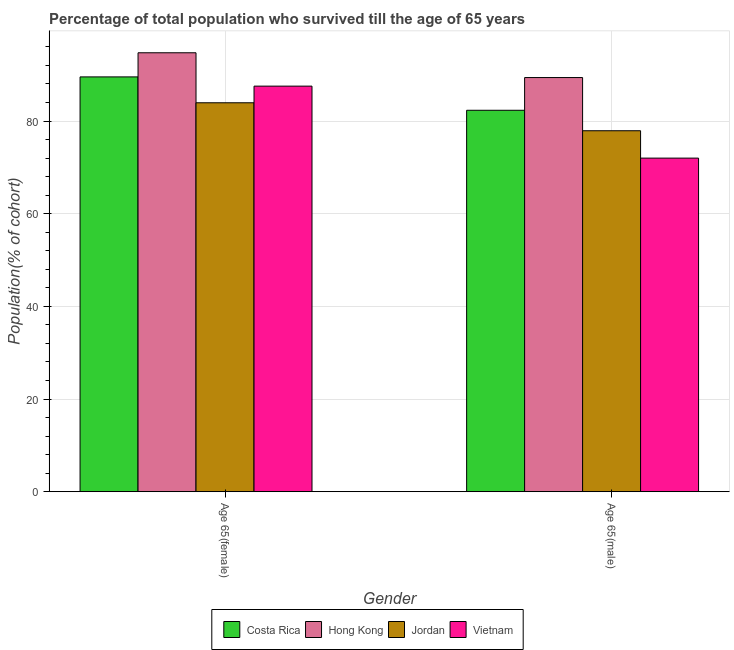How many groups of bars are there?
Give a very brief answer. 2. Are the number of bars per tick equal to the number of legend labels?
Give a very brief answer. Yes. Are the number of bars on each tick of the X-axis equal?
Provide a succinct answer. Yes. How many bars are there on the 2nd tick from the right?
Provide a short and direct response. 4. What is the label of the 2nd group of bars from the left?
Provide a succinct answer. Age 65(male). What is the percentage of male population who survived till age of 65 in Jordan?
Your answer should be compact. 77.9. Across all countries, what is the maximum percentage of male population who survived till age of 65?
Offer a very short reply. 89.37. Across all countries, what is the minimum percentage of female population who survived till age of 65?
Ensure brevity in your answer.  83.93. In which country was the percentage of male population who survived till age of 65 maximum?
Offer a very short reply. Hong Kong. In which country was the percentage of male population who survived till age of 65 minimum?
Ensure brevity in your answer.  Vietnam. What is the total percentage of male population who survived till age of 65 in the graph?
Provide a short and direct response. 321.58. What is the difference between the percentage of male population who survived till age of 65 in Hong Kong and that in Costa Rica?
Offer a very short reply. 7.06. What is the difference between the percentage of female population who survived till age of 65 in Vietnam and the percentage of male population who survived till age of 65 in Jordan?
Offer a very short reply. 9.63. What is the average percentage of male population who survived till age of 65 per country?
Offer a terse response. 80.39. What is the difference between the percentage of female population who survived till age of 65 and percentage of male population who survived till age of 65 in Vietnam?
Offer a very short reply. 15.53. In how many countries, is the percentage of male population who survived till age of 65 greater than 48 %?
Your response must be concise. 4. What is the ratio of the percentage of male population who survived till age of 65 in Hong Kong to that in Vietnam?
Provide a succinct answer. 1.24. In how many countries, is the percentage of female population who survived till age of 65 greater than the average percentage of female population who survived till age of 65 taken over all countries?
Offer a very short reply. 2. What does the 2nd bar from the left in Age 65(female) represents?
Provide a short and direct response. Hong Kong. What does the 1st bar from the right in Age 65(male) represents?
Offer a terse response. Vietnam. Are all the bars in the graph horizontal?
Your answer should be very brief. No. How many countries are there in the graph?
Keep it short and to the point. 4. Are the values on the major ticks of Y-axis written in scientific E-notation?
Provide a succinct answer. No. Does the graph contain any zero values?
Keep it short and to the point. No. Does the graph contain grids?
Offer a terse response. Yes. How many legend labels are there?
Your response must be concise. 4. How are the legend labels stacked?
Offer a terse response. Horizontal. What is the title of the graph?
Give a very brief answer. Percentage of total population who survived till the age of 65 years. Does "North America" appear as one of the legend labels in the graph?
Keep it short and to the point. No. What is the label or title of the Y-axis?
Offer a very short reply. Population(% of cohort). What is the Population(% of cohort) of Costa Rica in Age 65(female)?
Your response must be concise. 89.52. What is the Population(% of cohort) of Hong Kong in Age 65(female)?
Your response must be concise. 94.72. What is the Population(% of cohort) of Jordan in Age 65(female)?
Provide a short and direct response. 83.93. What is the Population(% of cohort) of Vietnam in Age 65(female)?
Give a very brief answer. 87.52. What is the Population(% of cohort) in Costa Rica in Age 65(male)?
Your answer should be compact. 82.32. What is the Population(% of cohort) in Hong Kong in Age 65(male)?
Your response must be concise. 89.37. What is the Population(% of cohort) of Jordan in Age 65(male)?
Give a very brief answer. 77.9. What is the Population(% of cohort) of Vietnam in Age 65(male)?
Provide a short and direct response. 71.99. Across all Gender, what is the maximum Population(% of cohort) of Costa Rica?
Your response must be concise. 89.52. Across all Gender, what is the maximum Population(% of cohort) in Hong Kong?
Offer a very short reply. 94.72. Across all Gender, what is the maximum Population(% of cohort) in Jordan?
Keep it short and to the point. 83.93. Across all Gender, what is the maximum Population(% of cohort) in Vietnam?
Give a very brief answer. 87.52. Across all Gender, what is the minimum Population(% of cohort) of Costa Rica?
Offer a terse response. 82.32. Across all Gender, what is the minimum Population(% of cohort) of Hong Kong?
Offer a very short reply. 89.37. Across all Gender, what is the minimum Population(% of cohort) in Jordan?
Offer a very short reply. 77.9. Across all Gender, what is the minimum Population(% of cohort) of Vietnam?
Provide a short and direct response. 71.99. What is the total Population(% of cohort) in Costa Rica in the graph?
Keep it short and to the point. 171.83. What is the total Population(% of cohort) of Hong Kong in the graph?
Provide a succinct answer. 184.1. What is the total Population(% of cohort) of Jordan in the graph?
Make the answer very short. 161.83. What is the total Population(% of cohort) of Vietnam in the graph?
Provide a short and direct response. 159.51. What is the difference between the Population(% of cohort) of Costa Rica in Age 65(female) and that in Age 65(male)?
Your answer should be very brief. 7.2. What is the difference between the Population(% of cohort) of Hong Kong in Age 65(female) and that in Age 65(male)?
Your answer should be very brief. 5.35. What is the difference between the Population(% of cohort) in Jordan in Age 65(female) and that in Age 65(male)?
Provide a short and direct response. 6.03. What is the difference between the Population(% of cohort) in Vietnam in Age 65(female) and that in Age 65(male)?
Your answer should be very brief. 15.54. What is the difference between the Population(% of cohort) in Costa Rica in Age 65(female) and the Population(% of cohort) in Hong Kong in Age 65(male)?
Offer a very short reply. 0.14. What is the difference between the Population(% of cohort) in Costa Rica in Age 65(female) and the Population(% of cohort) in Jordan in Age 65(male)?
Offer a terse response. 11.62. What is the difference between the Population(% of cohort) in Costa Rica in Age 65(female) and the Population(% of cohort) in Vietnam in Age 65(male)?
Your response must be concise. 17.53. What is the difference between the Population(% of cohort) in Hong Kong in Age 65(female) and the Population(% of cohort) in Jordan in Age 65(male)?
Keep it short and to the point. 16.82. What is the difference between the Population(% of cohort) in Hong Kong in Age 65(female) and the Population(% of cohort) in Vietnam in Age 65(male)?
Your answer should be very brief. 22.73. What is the difference between the Population(% of cohort) in Jordan in Age 65(female) and the Population(% of cohort) in Vietnam in Age 65(male)?
Ensure brevity in your answer.  11.94. What is the average Population(% of cohort) of Costa Rica per Gender?
Provide a succinct answer. 85.92. What is the average Population(% of cohort) of Hong Kong per Gender?
Your response must be concise. 92.05. What is the average Population(% of cohort) in Jordan per Gender?
Offer a very short reply. 80.92. What is the average Population(% of cohort) in Vietnam per Gender?
Offer a very short reply. 79.76. What is the difference between the Population(% of cohort) of Costa Rica and Population(% of cohort) of Hong Kong in Age 65(female)?
Give a very brief answer. -5.21. What is the difference between the Population(% of cohort) in Costa Rica and Population(% of cohort) in Jordan in Age 65(female)?
Make the answer very short. 5.58. What is the difference between the Population(% of cohort) in Costa Rica and Population(% of cohort) in Vietnam in Age 65(female)?
Your response must be concise. 1.99. What is the difference between the Population(% of cohort) in Hong Kong and Population(% of cohort) in Jordan in Age 65(female)?
Your answer should be very brief. 10.79. What is the difference between the Population(% of cohort) in Hong Kong and Population(% of cohort) in Vietnam in Age 65(female)?
Ensure brevity in your answer.  7.2. What is the difference between the Population(% of cohort) in Jordan and Population(% of cohort) in Vietnam in Age 65(female)?
Your answer should be very brief. -3.59. What is the difference between the Population(% of cohort) of Costa Rica and Population(% of cohort) of Hong Kong in Age 65(male)?
Make the answer very short. -7.06. What is the difference between the Population(% of cohort) of Costa Rica and Population(% of cohort) of Jordan in Age 65(male)?
Your answer should be compact. 4.42. What is the difference between the Population(% of cohort) in Costa Rica and Population(% of cohort) in Vietnam in Age 65(male)?
Give a very brief answer. 10.33. What is the difference between the Population(% of cohort) of Hong Kong and Population(% of cohort) of Jordan in Age 65(male)?
Offer a very short reply. 11.47. What is the difference between the Population(% of cohort) of Hong Kong and Population(% of cohort) of Vietnam in Age 65(male)?
Your response must be concise. 17.38. What is the difference between the Population(% of cohort) of Jordan and Population(% of cohort) of Vietnam in Age 65(male)?
Provide a succinct answer. 5.91. What is the ratio of the Population(% of cohort) of Costa Rica in Age 65(female) to that in Age 65(male)?
Offer a terse response. 1.09. What is the ratio of the Population(% of cohort) in Hong Kong in Age 65(female) to that in Age 65(male)?
Provide a succinct answer. 1.06. What is the ratio of the Population(% of cohort) in Jordan in Age 65(female) to that in Age 65(male)?
Make the answer very short. 1.08. What is the ratio of the Population(% of cohort) in Vietnam in Age 65(female) to that in Age 65(male)?
Ensure brevity in your answer.  1.22. What is the difference between the highest and the second highest Population(% of cohort) of Costa Rica?
Offer a very short reply. 7.2. What is the difference between the highest and the second highest Population(% of cohort) in Hong Kong?
Make the answer very short. 5.35. What is the difference between the highest and the second highest Population(% of cohort) in Jordan?
Provide a succinct answer. 6.03. What is the difference between the highest and the second highest Population(% of cohort) of Vietnam?
Make the answer very short. 15.54. What is the difference between the highest and the lowest Population(% of cohort) in Costa Rica?
Your response must be concise. 7.2. What is the difference between the highest and the lowest Population(% of cohort) of Hong Kong?
Keep it short and to the point. 5.35. What is the difference between the highest and the lowest Population(% of cohort) of Jordan?
Your response must be concise. 6.03. What is the difference between the highest and the lowest Population(% of cohort) of Vietnam?
Your answer should be compact. 15.54. 